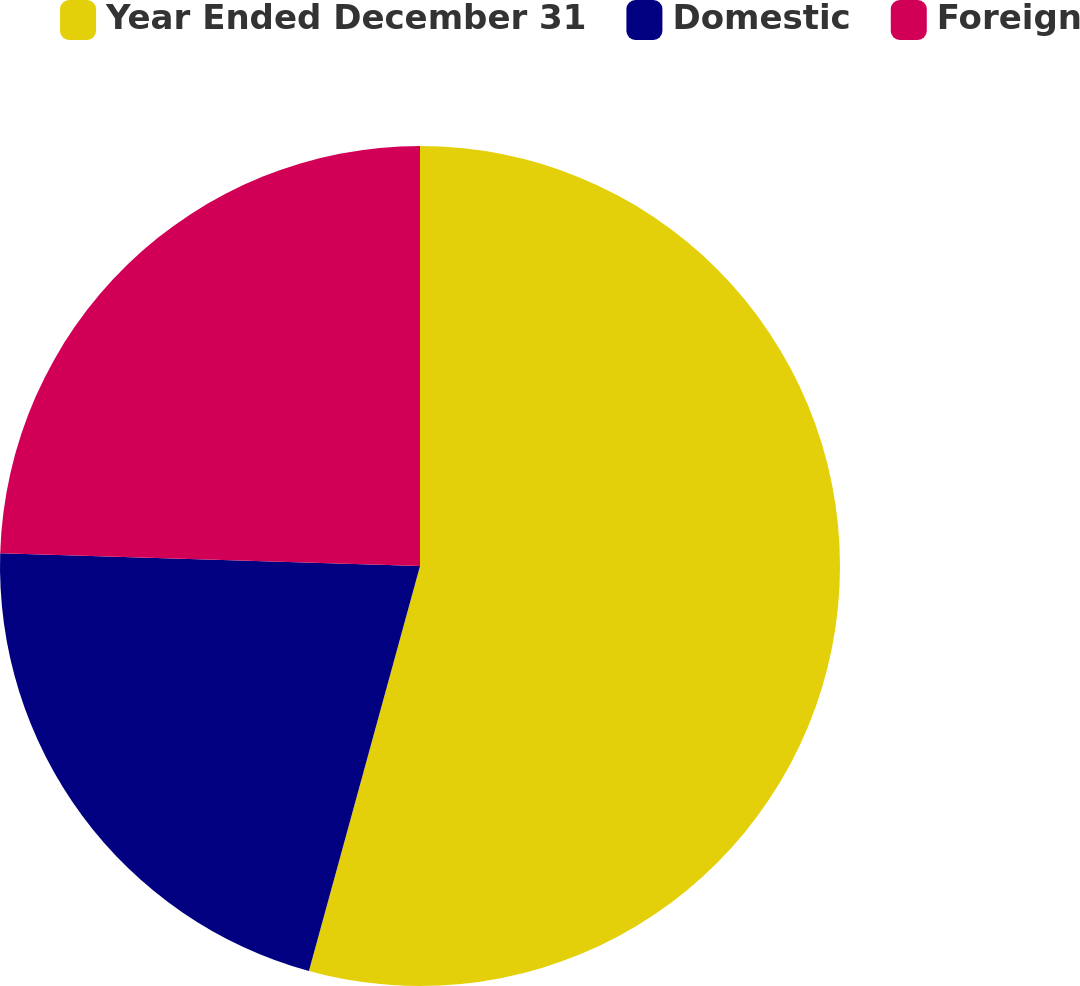<chart> <loc_0><loc_0><loc_500><loc_500><pie_chart><fcel>Year Ended December 31<fcel>Domestic<fcel>Foreign<nl><fcel>54.26%<fcel>21.22%<fcel>24.52%<nl></chart> 